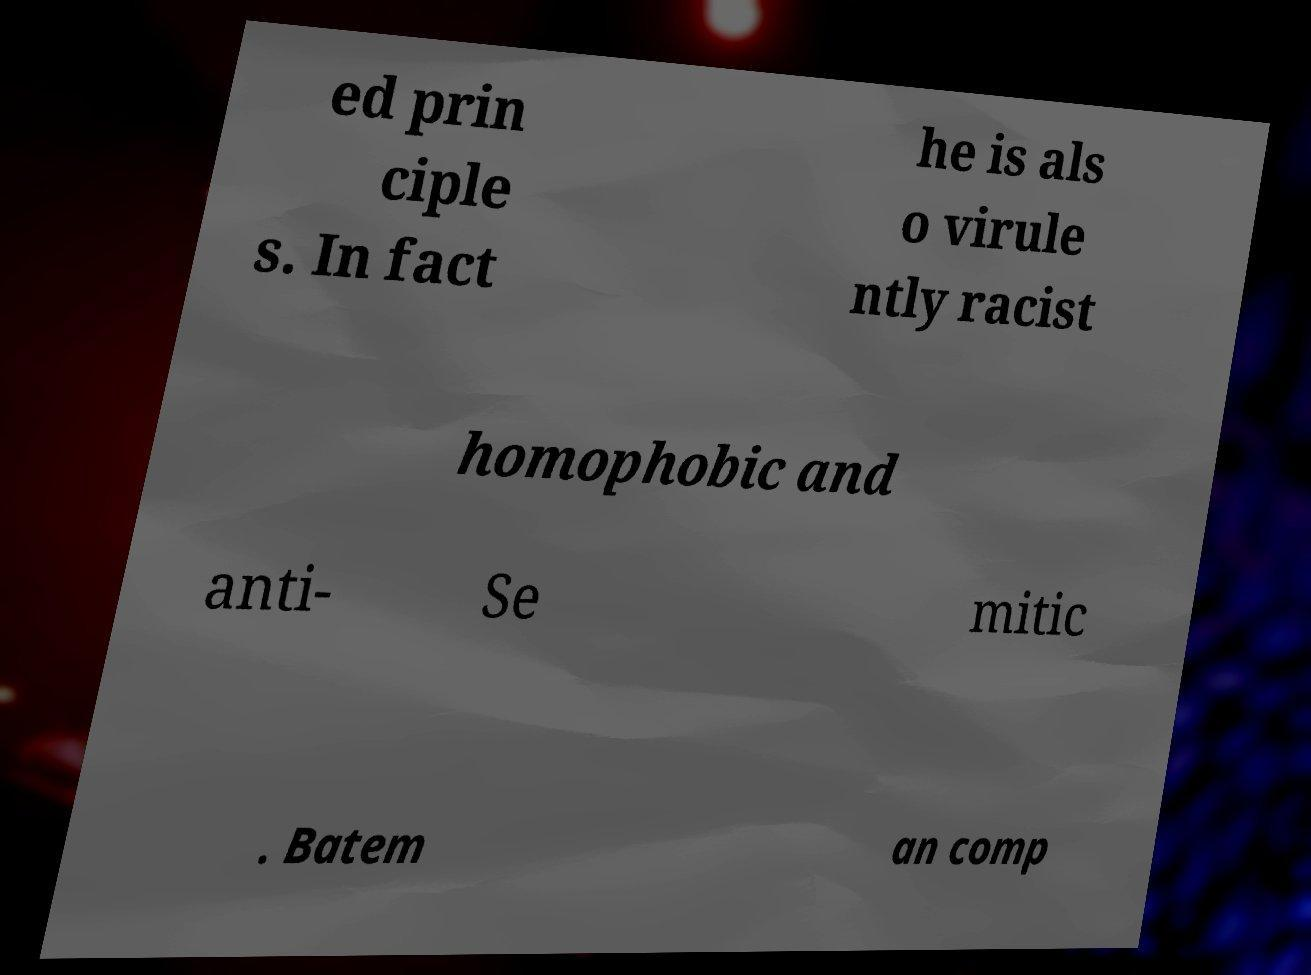There's text embedded in this image that I need extracted. Can you transcribe it verbatim? ed prin ciple s. In fact he is als o virule ntly racist homophobic and anti- Se mitic . Batem an comp 